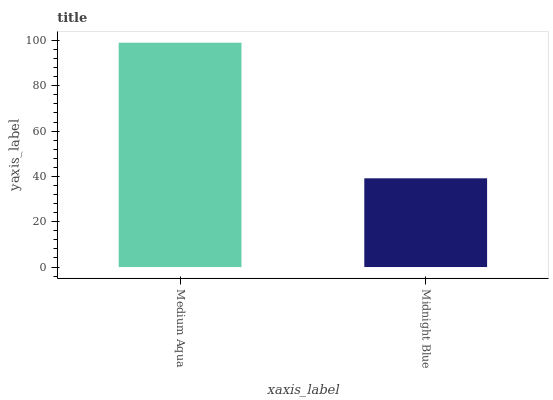Is Midnight Blue the minimum?
Answer yes or no. Yes. Is Medium Aqua the maximum?
Answer yes or no. Yes. Is Midnight Blue the maximum?
Answer yes or no. No. Is Medium Aqua greater than Midnight Blue?
Answer yes or no. Yes. Is Midnight Blue less than Medium Aqua?
Answer yes or no. Yes. Is Midnight Blue greater than Medium Aqua?
Answer yes or no. No. Is Medium Aqua less than Midnight Blue?
Answer yes or no. No. Is Medium Aqua the high median?
Answer yes or no. Yes. Is Midnight Blue the low median?
Answer yes or no. Yes. Is Midnight Blue the high median?
Answer yes or no. No. Is Medium Aqua the low median?
Answer yes or no. No. 